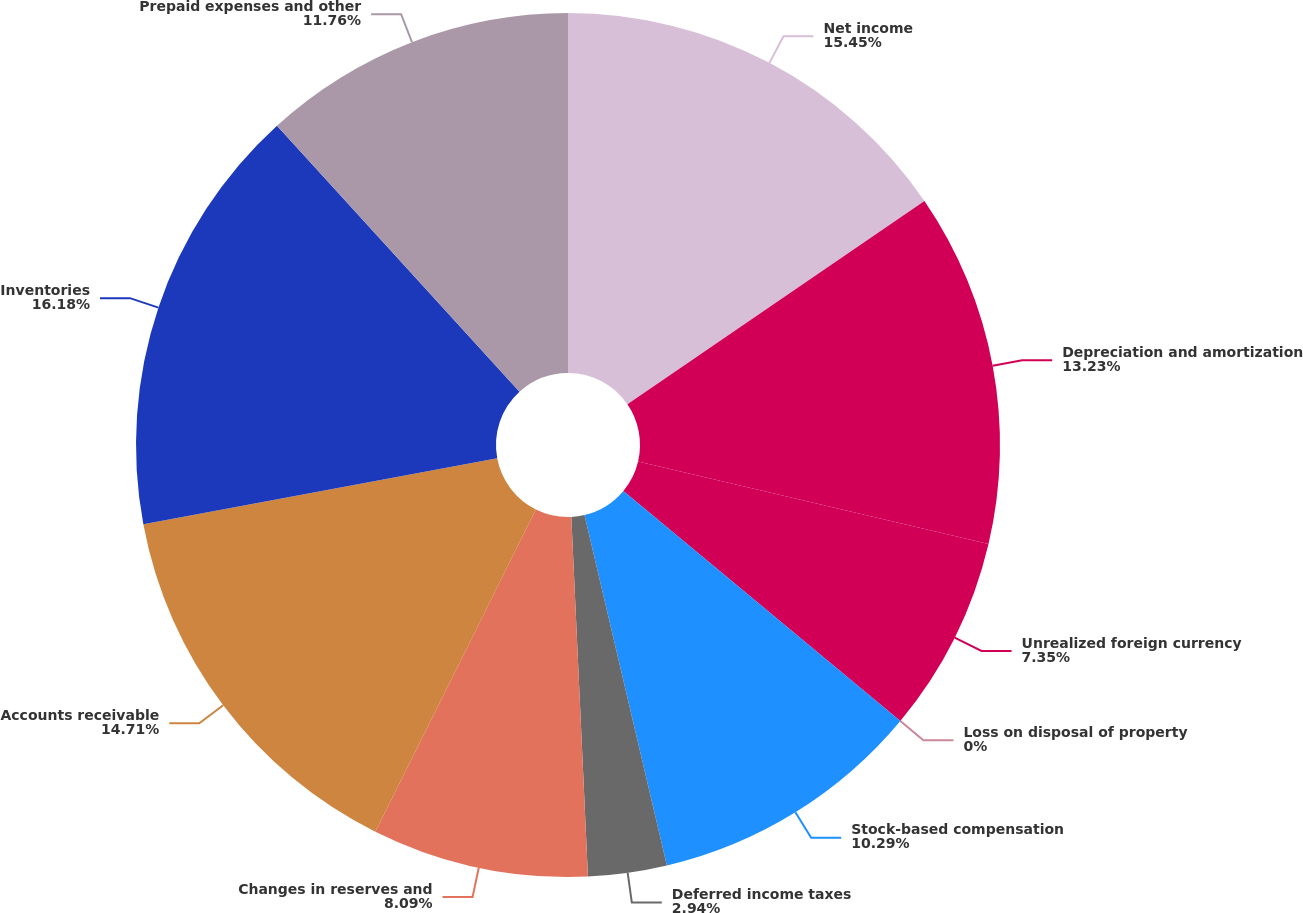<chart> <loc_0><loc_0><loc_500><loc_500><pie_chart><fcel>Net income<fcel>Depreciation and amortization<fcel>Unrealized foreign currency<fcel>Loss on disposal of property<fcel>Stock-based compensation<fcel>Deferred income taxes<fcel>Changes in reserves and<fcel>Accounts receivable<fcel>Inventories<fcel>Prepaid expenses and other<nl><fcel>15.44%<fcel>13.23%<fcel>7.35%<fcel>0.0%<fcel>10.29%<fcel>2.94%<fcel>8.09%<fcel>14.7%<fcel>16.17%<fcel>11.76%<nl></chart> 